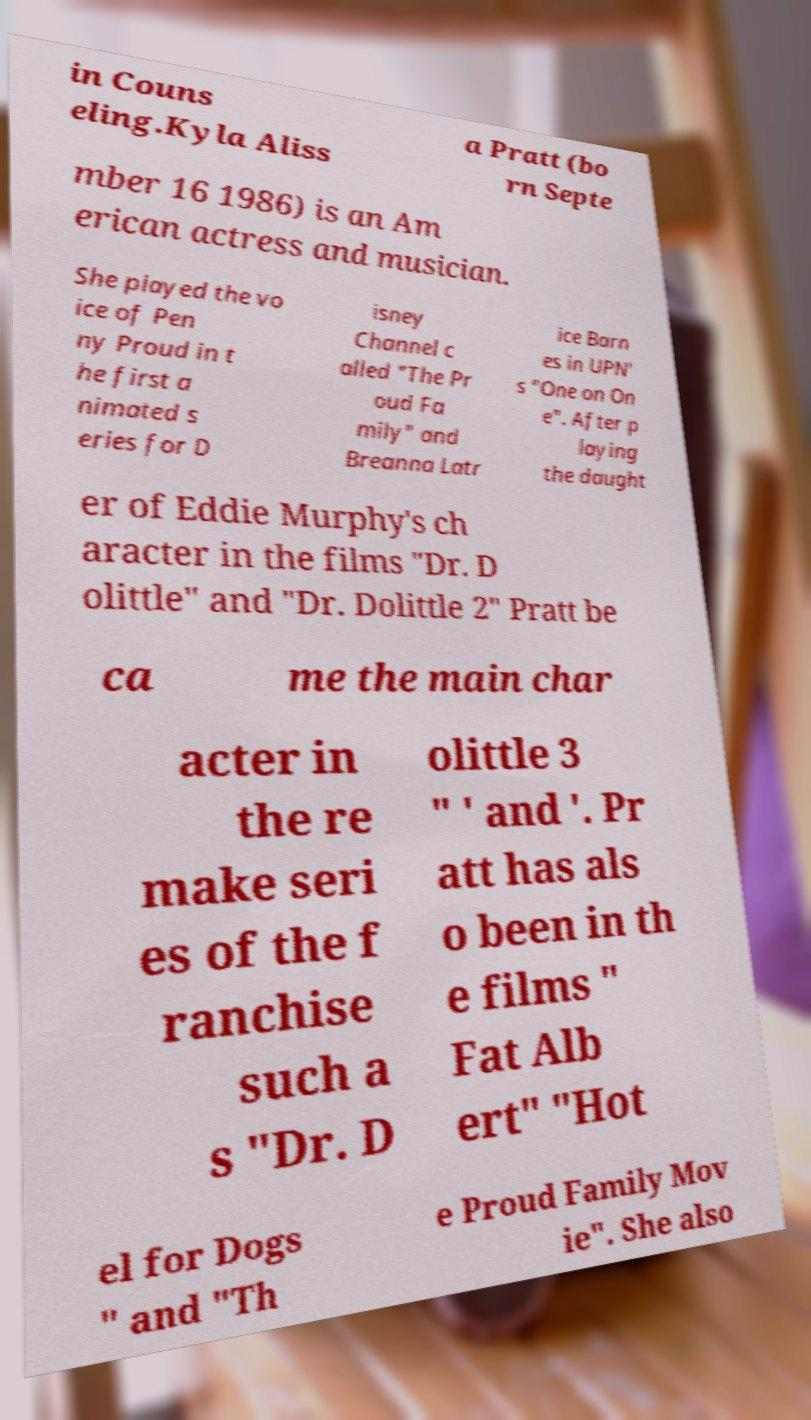There's text embedded in this image that I need extracted. Can you transcribe it verbatim? in Couns eling.Kyla Aliss a Pratt (bo rn Septe mber 16 1986) is an Am erican actress and musician. She played the vo ice of Pen ny Proud in t he first a nimated s eries for D isney Channel c alled "The Pr oud Fa mily" and Breanna Latr ice Barn es in UPN' s "One on On e". After p laying the daught er of Eddie Murphy's ch aracter in the films "Dr. D olittle" and "Dr. Dolittle 2" Pratt be ca me the main char acter in the re make seri es of the f ranchise such a s "Dr. D olittle 3 " ' and '. Pr att has als o been in th e films " Fat Alb ert" "Hot el for Dogs " and "Th e Proud Family Mov ie". She also 